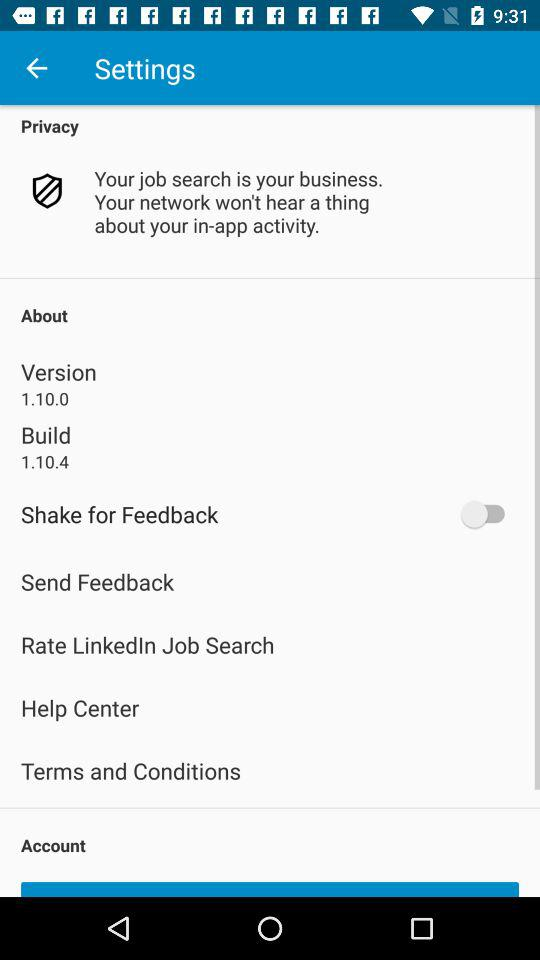Which version of the application is this? The version of the application is 1.10.0. 